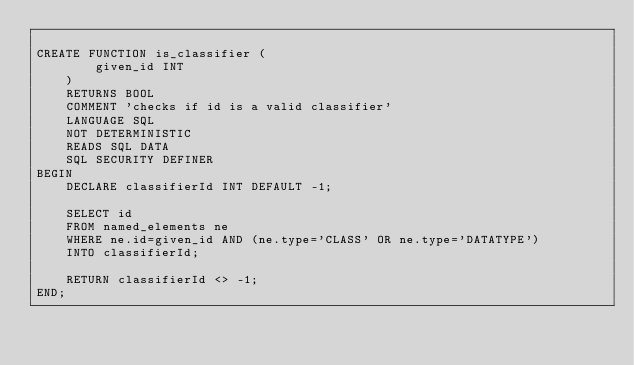Convert code to text. <code><loc_0><loc_0><loc_500><loc_500><_SQL_>
CREATE FUNCTION is_classifier (
		given_id INT
	)
	RETURNS BOOL
	COMMENT 'checks if id is a valid classifier'
	LANGUAGE SQL
	NOT DETERMINISTIC
	READS SQL DATA
	SQL SECURITY DEFINER
BEGIN
	DECLARE classifierId INT DEFAULT -1;
	
	SELECT id
	FROM named_elements ne
	WHERE ne.id=given_id AND (ne.type='CLASS' OR ne.type='DATATYPE')
	INTO classifierId;
	
	RETURN classifierId <> -1;
END;</code> 